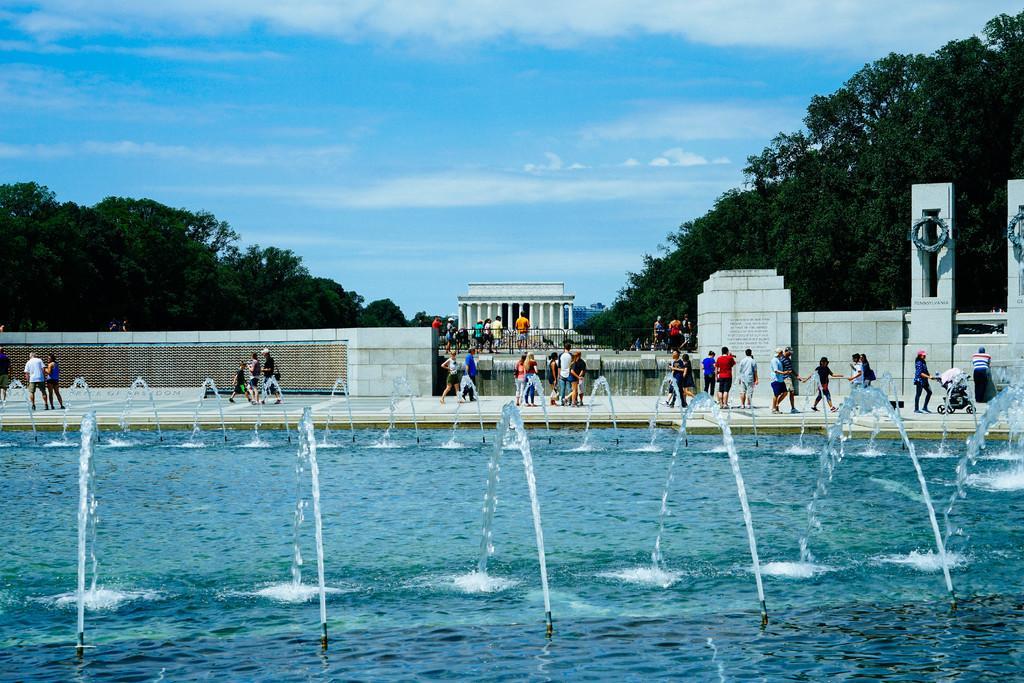In one or two sentences, can you explain what this image depicts? This is water and there are persons. In the background we can see a wall, pillars, trees, and sky with clouds. 